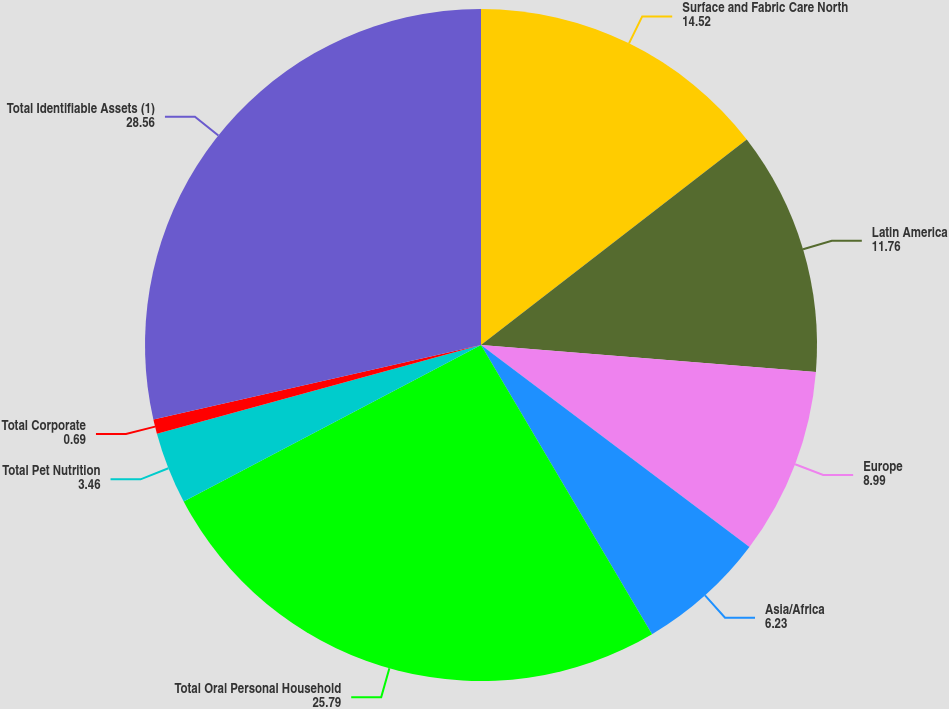<chart> <loc_0><loc_0><loc_500><loc_500><pie_chart><fcel>Surface and Fabric Care North<fcel>Latin America<fcel>Europe<fcel>Asia/Africa<fcel>Total Oral Personal Household<fcel>Total Pet Nutrition<fcel>Total Corporate<fcel>Total Identifiable Assets (1)<nl><fcel>14.52%<fcel>11.76%<fcel>8.99%<fcel>6.23%<fcel>25.79%<fcel>3.46%<fcel>0.69%<fcel>28.56%<nl></chart> 